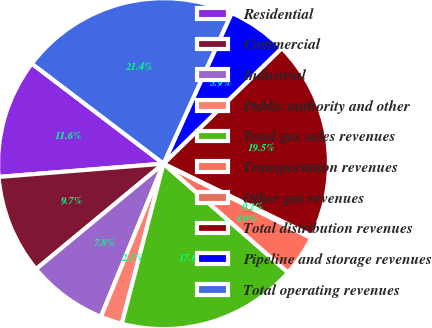Convert chart to OTSL. <chart><loc_0><loc_0><loc_500><loc_500><pie_chart><fcel>Residential<fcel>Commercial<fcel>Industrial<fcel>Public authority and other<fcel>Total gas sales revenues<fcel>Transportation revenues<fcel>Other gas revenues<fcel>Total distribution revenues<fcel>Pipeline and storage revenues<fcel>Total operating revenues<nl><fcel>11.62%<fcel>9.72%<fcel>7.82%<fcel>2.12%<fcel>17.62%<fcel>4.02%<fcel>0.22%<fcel>19.52%<fcel>5.92%<fcel>21.42%<nl></chart> 